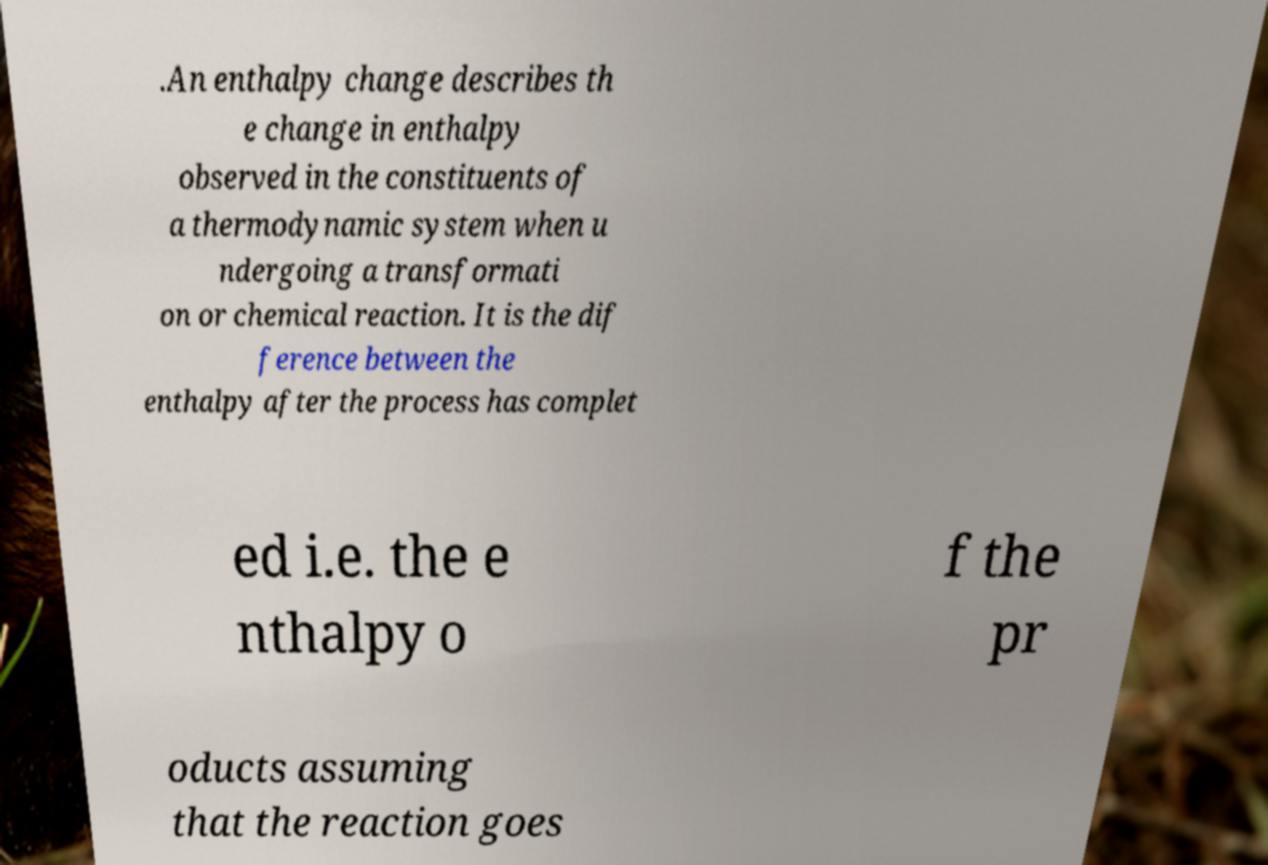Please read and relay the text visible in this image. What does it say? .An enthalpy change describes th e change in enthalpy observed in the constituents of a thermodynamic system when u ndergoing a transformati on or chemical reaction. It is the dif ference between the enthalpy after the process has complet ed i.e. the e nthalpy o f the pr oducts assuming that the reaction goes 